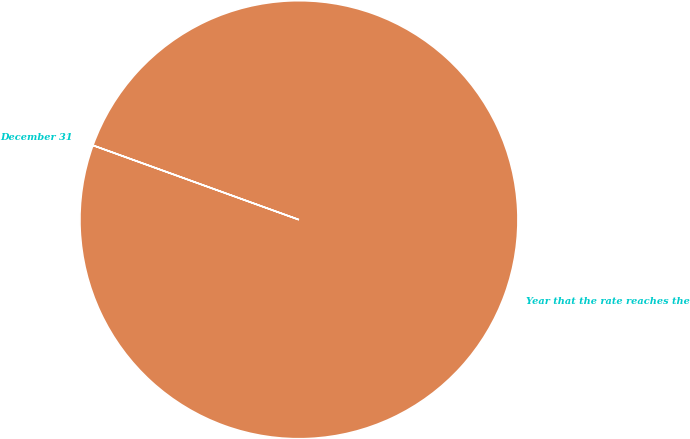Convert chart to OTSL. <chart><loc_0><loc_0><loc_500><loc_500><pie_chart><fcel>December 31<fcel>Year that the rate reaches the<nl><fcel>0.01%<fcel>99.99%<nl></chart> 